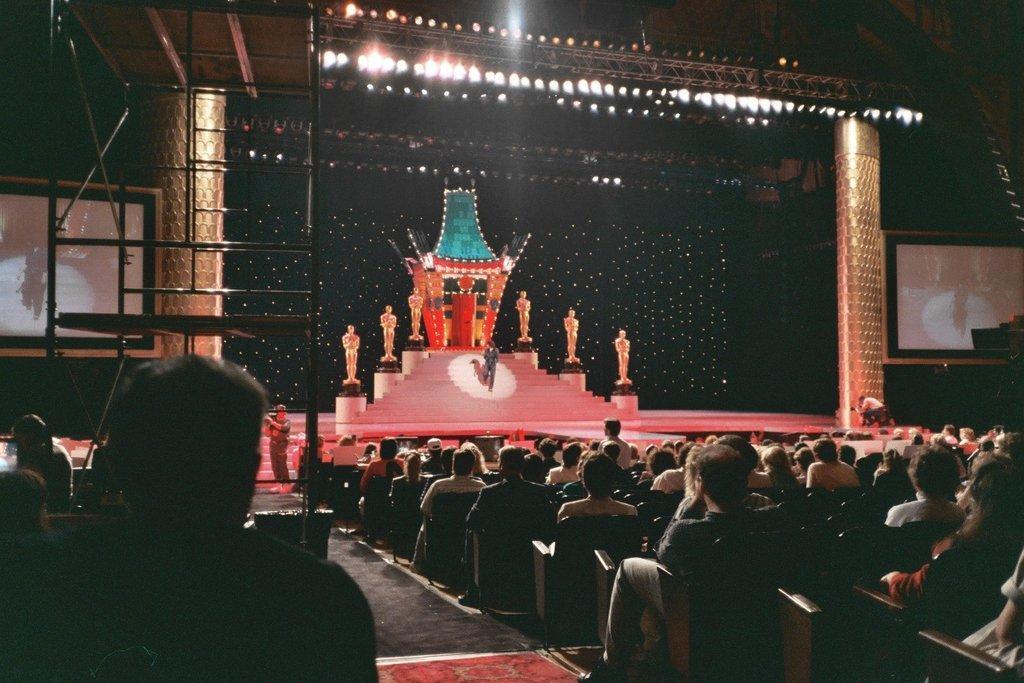How would you summarize this image in a sentence or two? In the picture I can see people sitting on chairs in front of a stage. On the stage I can see a people, stage lights and some other objects. On both sides of the image I can see projector screens some other objects. 